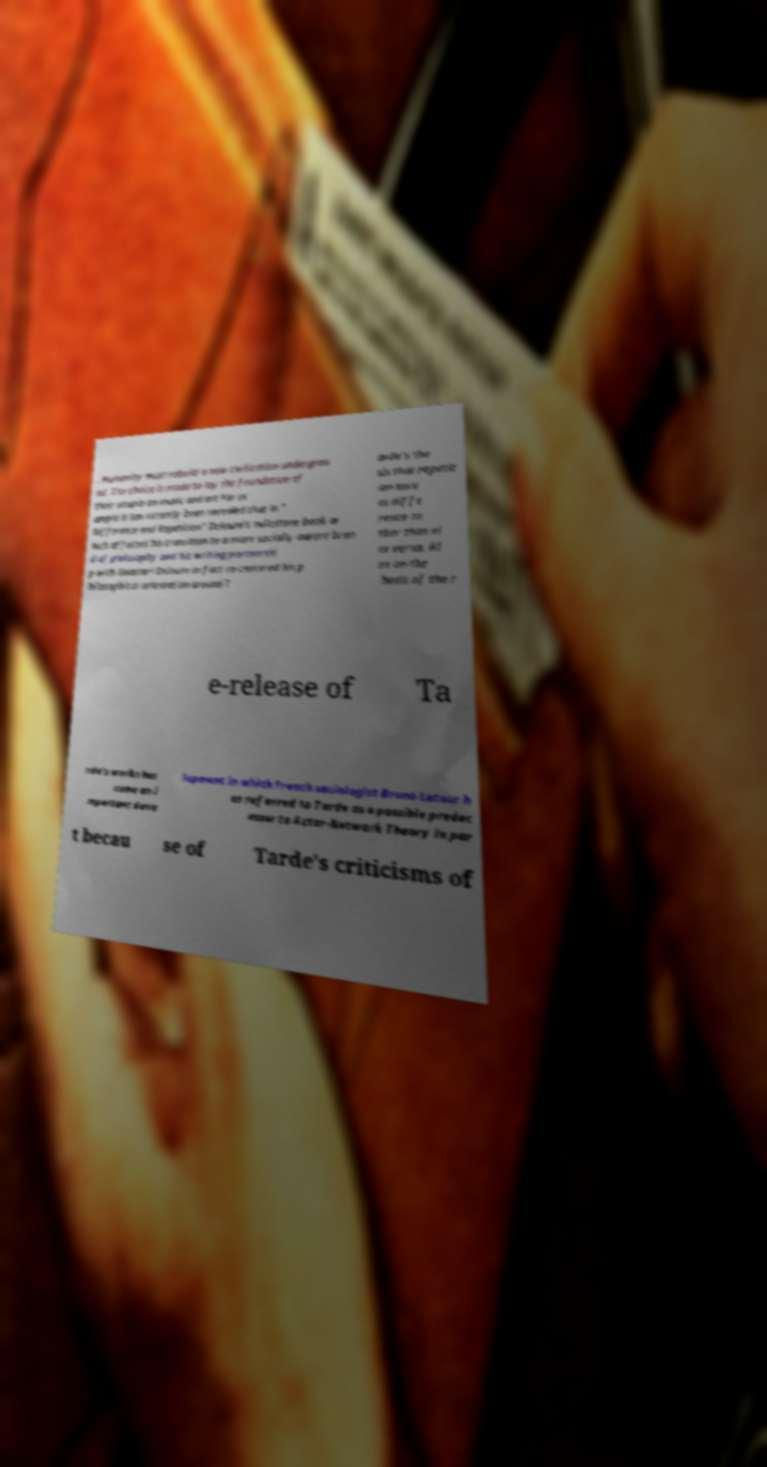Please read and relay the text visible in this image. What does it say? . Humanity must rebuild a new civilization undergrou nd. The choice is made to lay the foundation of their utopia on music and art.For ex ample it has recently been revealed that in " Difference and Repetition" Deleuze's milestone book w hich affected his transition to a more socially-aware bran d of philosophy and his writing partnershi p with Guattari Deleuze in fact re-centered his p hilosophical orientation around T arde's the sis that repetit ion serv es diffe rence ra ther than vi ce versa. Al so on the heels of the r e-release of Ta rde's works has come an i mportant deve lopment in which French sociologist Bruno Latour h as referred to Tarde as a possible predec essor to Actor-Network Theory in par t becau se of Tarde's criticisms of 